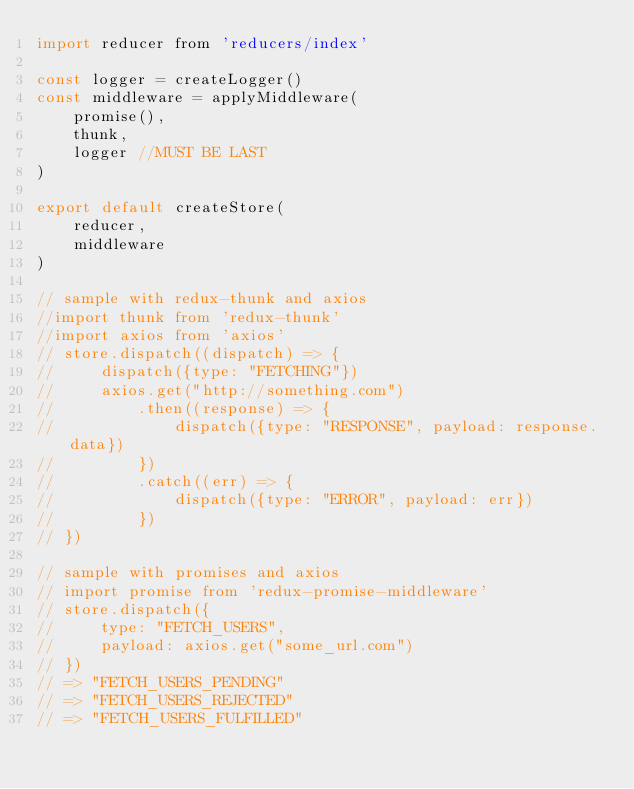<code> <loc_0><loc_0><loc_500><loc_500><_JavaScript_>import reducer from 'reducers/index'

const logger = createLogger()
const middleware = applyMiddleware(
    promise(),
    thunk,
    logger //MUST BE LAST
)

export default createStore(
    reducer,
    middleware
)

// sample with redux-thunk and axios
//import thunk from 'redux-thunk'
//import axios from 'axios'
// store.dispatch((dispatch) => {
//     dispatch({type: "FETCHING"})
//     axios.get("http://something.com")
//         .then((response) => {
//             dispatch({type: "RESPONSE", payload: response.data})
//         })
//         .catch((err) => {
//             dispatch({type: "ERROR", payload: err})
//         })
// })

// sample with promises and axios
// import promise from 'redux-promise-middleware'
// store.dispatch({
//     type: "FETCH_USERS",
//     payload: axios.get("some_url.com")
// })
// => "FETCH_USERS_PENDING"
// => "FETCH_USERS_REJECTED"
// => "FETCH_USERS_FULFILLED"</code> 